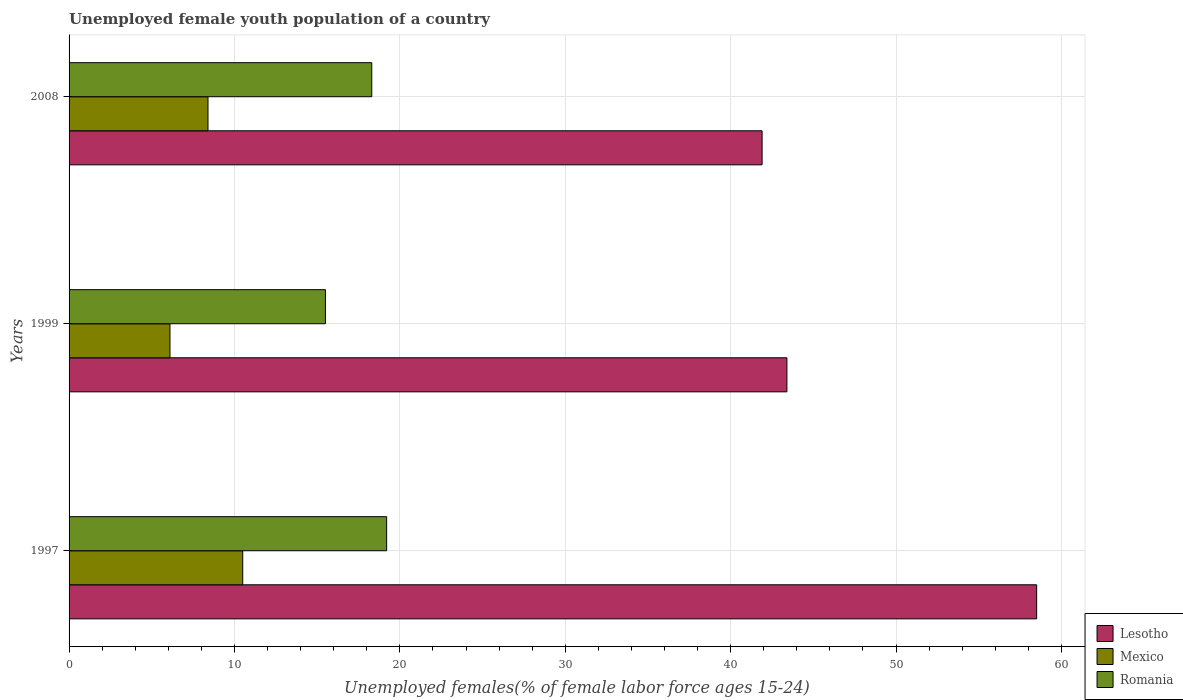How many bars are there on the 2nd tick from the bottom?
Offer a very short reply. 3. What is the label of the 2nd group of bars from the top?
Ensure brevity in your answer.  1999. In how many cases, is the number of bars for a given year not equal to the number of legend labels?
Offer a very short reply. 0. What is the percentage of unemployed female youth population in Lesotho in 1999?
Provide a succinct answer. 43.4. Across all years, what is the maximum percentage of unemployed female youth population in Lesotho?
Make the answer very short. 58.5. Across all years, what is the minimum percentage of unemployed female youth population in Lesotho?
Provide a short and direct response. 41.9. In which year was the percentage of unemployed female youth population in Romania minimum?
Keep it short and to the point. 1999. What is the total percentage of unemployed female youth population in Lesotho in the graph?
Make the answer very short. 143.8. What is the difference between the percentage of unemployed female youth population in Mexico in 1999 and that in 2008?
Provide a succinct answer. -2.3. What is the difference between the percentage of unemployed female youth population in Romania in 1997 and the percentage of unemployed female youth population in Lesotho in 1999?
Your answer should be very brief. -24.2. What is the average percentage of unemployed female youth population in Mexico per year?
Give a very brief answer. 8.33. In the year 1997, what is the difference between the percentage of unemployed female youth population in Mexico and percentage of unemployed female youth population in Romania?
Give a very brief answer. -8.7. In how many years, is the percentage of unemployed female youth population in Lesotho greater than 32 %?
Offer a terse response. 3. What is the ratio of the percentage of unemployed female youth population in Mexico in 1997 to that in 1999?
Give a very brief answer. 1.72. What is the difference between the highest and the second highest percentage of unemployed female youth population in Romania?
Make the answer very short. 0.9. What is the difference between the highest and the lowest percentage of unemployed female youth population in Lesotho?
Your response must be concise. 16.6. In how many years, is the percentage of unemployed female youth population in Romania greater than the average percentage of unemployed female youth population in Romania taken over all years?
Give a very brief answer. 2. What does the 1st bar from the bottom in 1997 represents?
Your answer should be very brief. Lesotho. Is it the case that in every year, the sum of the percentage of unemployed female youth population in Lesotho and percentage of unemployed female youth population in Mexico is greater than the percentage of unemployed female youth population in Romania?
Offer a terse response. Yes. Does the graph contain any zero values?
Offer a terse response. No. Does the graph contain grids?
Keep it short and to the point. Yes. How many legend labels are there?
Offer a very short reply. 3. What is the title of the graph?
Offer a very short reply. Unemployed female youth population of a country. What is the label or title of the X-axis?
Your answer should be compact. Unemployed females(% of female labor force ages 15-24). What is the label or title of the Y-axis?
Provide a succinct answer. Years. What is the Unemployed females(% of female labor force ages 15-24) in Lesotho in 1997?
Make the answer very short. 58.5. What is the Unemployed females(% of female labor force ages 15-24) in Romania in 1997?
Offer a very short reply. 19.2. What is the Unemployed females(% of female labor force ages 15-24) of Lesotho in 1999?
Offer a terse response. 43.4. What is the Unemployed females(% of female labor force ages 15-24) in Mexico in 1999?
Give a very brief answer. 6.1. What is the Unemployed females(% of female labor force ages 15-24) of Romania in 1999?
Provide a succinct answer. 15.5. What is the Unemployed females(% of female labor force ages 15-24) in Lesotho in 2008?
Keep it short and to the point. 41.9. What is the Unemployed females(% of female labor force ages 15-24) in Mexico in 2008?
Your answer should be compact. 8.4. What is the Unemployed females(% of female labor force ages 15-24) of Romania in 2008?
Give a very brief answer. 18.3. Across all years, what is the maximum Unemployed females(% of female labor force ages 15-24) of Lesotho?
Offer a terse response. 58.5. Across all years, what is the maximum Unemployed females(% of female labor force ages 15-24) of Mexico?
Keep it short and to the point. 10.5. Across all years, what is the maximum Unemployed females(% of female labor force ages 15-24) in Romania?
Keep it short and to the point. 19.2. Across all years, what is the minimum Unemployed females(% of female labor force ages 15-24) in Lesotho?
Offer a terse response. 41.9. Across all years, what is the minimum Unemployed females(% of female labor force ages 15-24) of Mexico?
Offer a terse response. 6.1. What is the total Unemployed females(% of female labor force ages 15-24) in Lesotho in the graph?
Your response must be concise. 143.8. What is the difference between the Unemployed females(% of female labor force ages 15-24) in Lesotho in 1997 and that in 1999?
Provide a succinct answer. 15.1. What is the difference between the Unemployed females(% of female labor force ages 15-24) of Romania in 1997 and that in 1999?
Offer a very short reply. 3.7. What is the difference between the Unemployed females(% of female labor force ages 15-24) in Mexico in 1997 and that in 2008?
Provide a succinct answer. 2.1. What is the difference between the Unemployed females(% of female labor force ages 15-24) in Lesotho in 1999 and that in 2008?
Make the answer very short. 1.5. What is the difference between the Unemployed females(% of female labor force ages 15-24) of Lesotho in 1997 and the Unemployed females(% of female labor force ages 15-24) of Mexico in 1999?
Provide a short and direct response. 52.4. What is the difference between the Unemployed females(% of female labor force ages 15-24) in Lesotho in 1997 and the Unemployed females(% of female labor force ages 15-24) in Romania in 1999?
Your response must be concise. 43. What is the difference between the Unemployed females(% of female labor force ages 15-24) of Mexico in 1997 and the Unemployed females(% of female labor force ages 15-24) of Romania in 1999?
Your response must be concise. -5. What is the difference between the Unemployed females(% of female labor force ages 15-24) in Lesotho in 1997 and the Unemployed females(% of female labor force ages 15-24) in Mexico in 2008?
Provide a short and direct response. 50.1. What is the difference between the Unemployed females(% of female labor force ages 15-24) of Lesotho in 1997 and the Unemployed females(% of female labor force ages 15-24) of Romania in 2008?
Your answer should be very brief. 40.2. What is the difference between the Unemployed females(% of female labor force ages 15-24) in Lesotho in 1999 and the Unemployed females(% of female labor force ages 15-24) in Romania in 2008?
Offer a very short reply. 25.1. What is the difference between the Unemployed females(% of female labor force ages 15-24) of Mexico in 1999 and the Unemployed females(% of female labor force ages 15-24) of Romania in 2008?
Your answer should be very brief. -12.2. What is the average Unemployed females(% of female labor force ages 15-24) in Lesotho per year?
Offer a terse response. 47.93. What is the average Unemployed females(% of female labor force ages 15-24) of Mexico per year?
Make the answer very short. 8.33. What is the average Unemployed females(% of female labor force ages 15-24) in Romania per year?
Make the answer very short. 17.67. In the year 1997, what is the difference between the Unemployed females(% of female labor force ages 15-24) of Lesotho and Unemployed females(% of female labor force ages 15-24) of Romania?
Keep it short and to the point. 39.3. In the year 1997, what is the difference between the Unemployed females(% of female labor force ages 15-24) in Mexico and Unemployed females(% of female labor force ages 15-24) in Romania?
Ensure brevity in your answer.  -8.7. In the year 1999, what is the difference between the Unemployed females(% of female labor force ages 15-24) in Lesotho and Unemployed females(% of female labor force ages 15-24) in Mexico?
Your answer should be compact. 37.3. In the year 1999, what is the difference between the Unemployed females(% of female labor force ages 15-24) in Lesotho and Unemployed females(% of female labor force ages 15-24) in Romania?
Offer a terse response. 27.9. In the year 1999, what is the difference between the Unemployed females(% of female labor force ages 15-24) of Mexico and Unemployed females(% of female labor force ages 15-24) of Romania?
Offer a terse response. -9.4. In the year 2008, what is the difference between the Unemployed females(% of female labor force ages 15-24) of Lesotho and Unemployed females(% of female labor force ages 15-24) of Mexico?
Ensure brevity in your answer.  33.5. In the year 2008, what is the difference between the Unemployed females(% of female labor force ages 15-24) of Lesotho and Unemployed females(% of female labor force ages 15-24) of Romania?
Give a very brief answer. 23.6. In the year 2008, what is the difference between the Unemployed females(% of female labor force ages 15-24) of Mexico and Unemployed females(% of female labor force ages 15-24) of Romania?
Provide a short and direct response. -9.9. What is the ratio of the Unemployed females(% of female labor force ages 15-24) of Lesotho in 1997 to that in 1999?
Provide a succinct answer. 1.35. What is the ratio of the Unemployed females(% of female labor force ages 15-24) of Mexico in 1997 to that in 1999?
Offer a very short reply. 1.72. What is the ratio of the Unemployed females(% of female labor force ages 15-24) in Romania in 1997 to that in 1999?
Provide a succinct answer. 1.24. What is the ratio of the Unemployed females(% of female labor force ages 15-24) of Lesotho in 1997 to that in 2008?
Keep it short and to the point. 1.4. What is the ratio of the Unemployed females(% of female labor force ages 15-24) of Romania in 1997 to that in 2008?
Your response must be concise. 1.05. What is the ratio of the Unemployed females(% of female labor force ages 15-24) in Lesotho in 1999 to that in 2008?
Your answer should be compact. 1.04. What is the ratio of the Unemployed females(% of female labor force ages 15-24) in Mexico in 1999 to that in 2008?
Your response must be concise. 0.73. What is the ratio of the Unemployed females(% of female labor force ages 15-24) in Romania in 1999 to that in 2008?
Offer a terse response. 0.85. What is the difference between the highest and the second highest Unemployed females(% of female labor force ages 15-24) in Lesotho?
Your answer should be compact. 15.1. What is the difference between the highest and the second highest Unemployed females(% of female labor force ages 15-24) of Romania?
Make the answer very short. 0.9. What is the difference between the highest and the lowest Unemployed females(% of female labor force ages 15-24) in Lesotho?
Offer a terse response. 16.6. 